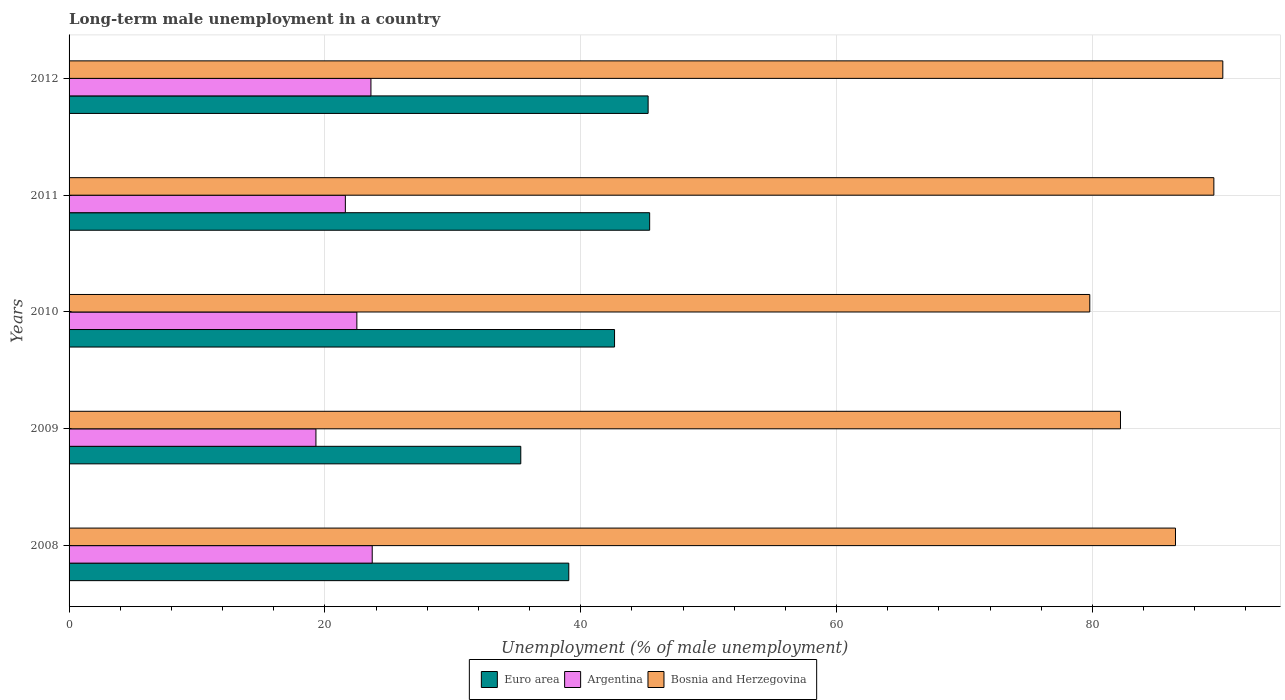How many different coloured bars are there?
Keep it short and to the point. 3. Are the number of bars on each tick of the Y-axis equal?
Offer a terse response. Yes. What is the percentage of long-term unemployed male population in Euro area in 2008?
Provide a succinct answer. 39.07. Across all years, what is the maximum percentage of long-term unemployed male population in Bosnia and Herzegovina?
Your answer should be very brief. 90.2. Across all years, what is the minimum percentage of long-term unemployed male population in Euro area?
Offer a terse response. 35.32. In which year was the percentage of long-term unemployed male population in Bosnia and Herzegovina maximum?
Give a very brief answer. 2012. What is the total percentage of long-term unemployed male population in Euro area in the graph?
Your response must be concise. 207.69. What is the difference between the percentage of long-term unemployed male population in Bosnia and Herzegovina in 2008 and that in 2012?
Give a very brief answer. -3.7. What is the difference between the percentage of long-term unemployed male population in Argentina in 2008 and the percentage of long-term unemployed male population in Bosnia and Herzegovina in 2012?
Your answer should be very brief. -66.5. What is the average percentage of long-term unemployed male population in Argentina per year?
Your response must be concise. 22.14. In the year 2008, what is the difference between the percentage of long-term unemployed male population in Bosnia and Herzegovina and percentage of long-term unemployed male population in Argentina?
Offer a very short reply. 62.8. What is the ratio of the percentage of long-term unemployed male population in Bosnia and Herzegovina in 2011 to that in 2012?
Provide a succinct answer. 0.99. Is the percentage of long-term unemployed male population in Euro area in 2009 less than that in 2011?
Give a very brief answer. Yes. What is the difference between the highest and the second highest percentage of long-term unemployed male population in Argentina?
Offer a very short reply. 0.1. What is the difference between the highest and the lowest percentage of long-term unemployed male population in Argentina?
Make the answer very short. 4.4. In how many years, is the percentage of long-term unemployed male population in Argentina greater than the average percentage of long-term unemployed male population in Argentina taken over all years?
Offer a terse response. 3. Is the sum of the percentage of long-term unemployed male population in Euro area in 2009 and 2011 greater than the maximum percentage of long-term unemployed male population in Argentina across all years?
Provide a short and direct response. Yes. What does the 3rd bar from the top in 2012 represents?
Ensure brevity in your answer.  Euro area. What does the 3rd bar from the bottom in 2009 represents?
Offer a terse response. Bosnia and Herzegovina. Is it the case that in every year, the sum of the percentage of long-term unemployed male population in Euro area and percentage of long-term unemployed male population in Argentina is greater than the percentage of long-term unemployed male population in Bosnia and Herzegovina?
Provide a succinct answer. No. How many bars are there?
Provide a short and direct response. 15. Are all the bars in the graph horizontal?
Give a very brief answer. Yes. How many years are there in the graph?
Your answer should be compact. 5. Are the values on the major ticks of X-axis written in scientific E-notation?
Keep it short and to the point. No. Does the graph contain any zero values?
Offer a very short reply. No. How many legend labels are there?
Give a very brief answer. 3. How are the legend labels stacked?
Offer a very short reply. Horizontal. What is the title of the graph?
Make the answer very short. Long-term male unemployment in a country. What is the label or title of the X-axis?
Give a very brief answer. Unemployment (% of male unemployment). What is the Unemployment (% of male unemployment) in Euro area in 2008?
Offer a terse response. 39.07. What is the Unemployment (% of male unemployment) of Argentina in 2008?
Offer a terse response. 23.7. What is the Unemployment (% of male unemployment) in Bosnia and Herzegovina in 2008?
Provide a succinct answer. 86.5. What is the Unemployment (% of male unemployment) of Euro area in 2009?
Keep it short and to the point. 35.32. What is the Unemployment (% of male unemployment) of Argentina in 2009?
Provide a short and direct response. 19.3. What is the Unemployment (% of male unemployment) in Bosnia and Herzegovina in 2009?
Provide a short and direct response. 82.2. What is the Unemployment (% of male unemployment) in Euro area in 2010?
Your answer should be compact. 42.65. What is the Unemployment (% of male unemployment) of Bosnia and Herzegovina in 2010?
Your answer should be very brief. 79.8. What is the Unemployment (% of male unemployment) of Euro area in 2011?
Make the answer very short. 45.39. What is the Unemployment (% of male unemployment) in Argentina in 2011?
Offer a very short reply. 21.6. What is the Unemployment (% of male unemployment) in Bosnia and Herzegovina in 2011?
Offer a very short reply. 89.5. What is the Unemployment (% of male unemployment) in Euro area in 2012?
Keep it short and to the point. 45.27. What is the Unemployment (% of male unemployment) of Argentina in 2012?
Offer a very short reply. 23.6. What is the Unemployment (% of male unemployment) in Bosnia and Herzegovina in 2012?
Give a very brief answer. 90.2. Across all years, what is the maximum Unemployment (% of male unemployment) of Euro area?
Make the answer very short. 45.39. Across all years, what is the maximum Unemployment (% of male unemployment) of Argentina?
Your answer should be very brief. 23.7. Across all years, what is the maximum Unemployment (% of male unemployment) in Bosnia and Herzegovina?
Give a very brief answer. 90.2. Across all years, what is the minimum Unemployment (% of male unemployment) of Euro area?
Offer a very short reply. 35.32. Across all years, what is the minimum Unemployment (% of male unemployment) in Argentina?
Keep it short and to the point. 19.3. Across all years, what is the minimum Unemployment (% of male unemployment) in Bosnia and Herzegovina?
Ensure brevity in your answer.  79.8. What is the total Unemployment (% of male unemployment) of Euro area in the graph?
Offer a very short reply. 207.69. What is the total Unemployment (% of male unemployment) of Argentina in the graph?
Keep it short and to the point. 110.7. What is the total Unemployment (% of male unemployment) in Bosnia and Herzegovina in the graph?
Offer a very short reply. 428.2. What is the difference between the Unemployment (% of male unemployment) of Euro area in 2008 and that in 2009?
Ensure brevity in your answer.  3.75. What is the difference between the Unemployment (% of male unemployment) in Bosnia and Herzegovina in 2008 and that in 2009?
Offer a terse response. 4.3. What is the difference between the Unemployment (% of male unemployment) in Euro area in 2008 and that in 2010?
Your response must be concise. -3.58. What is the difference between the Unemployment (% of male unemployment) in Euro area in 2008 and that in 2011?
Your answer should be very brief. -6.32. What is the difference between the Unemployment (% of male unemployment) in Euro area in 2008 and that in 2012?
Your answer should be compact. -6.2. What is the difference between the Unemployment (% of male unemployment) of Euro area in 2009 and that in 2010?
Offer a very short reply. -7.33. What is the difference between the Unemployment (% of male unemployment) of Argentina in 2009 and that in 2010?
Your answer should be very brief. -3.2. What is the difference between the Unemployment (% of male unemployment) of Euro area in 2009 and that in 2011?
Give a very brief answer. -10.07. What is the difference between the Unemployment (% of male unemployment) of Euro area in 2009 and that in 2012?
Your answer should be compact. -9.96. What is the difference between the Unemployment (% of male unemployment) of Euro area in 2010 and that in 2011?
Make the answer very short. -2.74. What is the difference between the Unemployment (% of male unemployment) in Argentina in 2010 and that in 2011?
Ensure brevity in your answer.  0.9. What is the difference between the Unemployment (% of male unemployment) in Bosnia and Herzegovina in 2010 and that in 2011?
Keep it short and to the point. -9.7. What is the difference between the Unemployment (% of male unemployment) of Euro area in 2010 and that in 2012?
Make the answer very short. -2.63. What is the difference between the Unemployment (% of male unemployment) of Bosnia and Herzegovina in 2010 and that in 2012?
Give a very brief answer. -10.4. What is the difference between the Unemployment (% of male unemployment) of Euro area in 2011 and that in 2012?
Offer a very short reply. 0.12. What is the difference between the Unemployment (% of male unemployment) of Argentina in 2011 and that in 2012?
Offer a very short reply. -2. What is the difference between the Unemployment (% of male unemployment) of Bosnia and Herzegovina in 2011 and that in 2012?
Keep it short and to the point. -0.7. What is the difference between the Unemployment (% of male unemployment) in Euro area in 2008 and the Unemployment (% of male unemployment) in Argentina in 2009?
Make the answer very short. 19.77. What is the difference between the Unemployment (% of male unemployment) of Euro area in 2008 and the Unemployment (% of male unemployment) of Bosnia and Herzegovina in 2009?
Your answer should be very brief. -43.13. What is the difference between the Unemployment (% of male unemployment) of Argentina in 2008 and the Unemployment (% of male unemployment) of Bosnia and Herzegovina in 2009?
Give a very brief answer. -58.5. What is the difference between the Unemployment (% of male unemployment) in Euro area in 2008 and the Unemployment (% of male unemployment) in Argentina in 2010?
Provide a succinct answer. 16.57. What is the difference between the Unemployment (% of male unemployment) in Euro area in 2008 and the Unemployment (% of male unemployment) in Bosnia and Herzegovina in 2010?
Provide a succinct answer. -40.73. What is the difference between the Unemployment (% of male unemployment) of Argentina in 2008 and the Unemployment (% of male unemployment) of Bosnia and Herzegovina in 2010?
Offer a terse response. -56.1. What is the difference between the Unemployment (% of male unemployment) in Euro area in 2008 and the Unemployment (% of male unemployment) in Argentina in 2011?
Provide a succinct answer. 17.47. What is the difference between the Unemployment (% of male unemployment) of Euro area in 2008 and the Unemployment (% of male unemployment) of Bosnia and Herzegovina in 2011?
Your answer should be very brief. -50.43. What is the difference between the Unemployment (% of male unemployment) of Argentina in 2008 and the Unemployment (% of male unemployment) of Bosnia and Herzegovina in 2011?
Your response must be concise. -65.8. What is the difference between the Unemployment (% of male unemployment) in Euro area in 2008 and the Unemployment (% of male unemployment) in Argentina in 2012?
Provide a succinct answer. 15.47. What is the difference between the Unemployment (% of male unemployment) of Euro area in 2008 and the Unemployment (% of male unemployment) of Bosnia and Herzegovina in 2012?
Provide a succinct answer. -51.13. What is the difference between the Unemployment (% of male unemployment) of Argentina in 2008 and the Unemployment (% of male unemployment) of Bosnia and Herzegovina in 2012?
Ensure brevity in your answer.  -66.5. What is the difference between the Unemployment (% of male unemployment) of Euro area in 2009 and the Unemployment (% of male unemployment) of Argentina in 2010?
Provide a short and direct response. 12.82. What is the difference between the Unemployment (% of male unemployment) in Euro area in 2009 and the Unemployment (% of male unemployment) in Bosnia and Herzegovina in 2010?
Ensure brevity in your answer.  -44.48. What is the difference between the Unemployment (% of male unemployment) of Argentina in 2009 and the Unemployment (% of male unemployment) of Bosnia and Herzegovina in 2010?
Offer a terse response. -60.5. What is the difference between the Unemployment (% of male unemployment) in Euro area in 2009 and the Unemployment (% of male unemployment) in Argentina in 2011?
Keep it short and to the point. 13.72. What is the difference between the Unemployment (% of male unemployment) in Euro area in 2009 and the Unemployment (% of male unemployment) in Bosnia and Herzegovina in 2011?
Provide a short and direct response. -54.18. What is the difference between the Unemployment (% of male unemployment) of Argentina in 2009 and the Unemployment (% of male unemployment) of Bosnia and Herzegovina in 2011?
Give a very brief answer. -70.2. What is the difference between the Unemployment (% of male unemployment) of Euro area in 2009 and the Unemployment (% of male unemployment) of Argentina in 2012?
Provide a short and direct response. 11.72. What is the difference between the Unemployment (% of male unemployment) of Euro area in 2009 and the Unemployment (% of male unemployment) of Bosnia and Herzegovina in 2012?
Give a very brief answer. -54.88. What is the difference between the Unemployment (% of male unemployment) in Argentina in 2009 and the Unemployment (% of male unemployment) in Bosnia and Herzegovina in 2012?
Your response must be concise. -70.9. What is the difference between the Unemployment (% of male unemployment) of Euro area in 2010 and the Unemployment (% of male unemployment) of Argentina in 2011?
Provide a succinct answer. 21.05. What is the difference between the Unemployment (% of male unemployment) of Euro area in 2010 and the Unemployment (% of male unemployment) of Bosnia and Herzegovina in 2011?
Your answer should be compact. -46.85. What is the difference between the Unemployment (% of male unemployment) in Argentina in 2010 and the Unemployment (% of male unemployment) in Bosnia and Herzegovina in 2011?
Make the answer very short. -67. What is the difference between the Unemployment (% of male unemployment) in Euro area in 2010 and the Unemployment (% of male unemployment) in Argentina in 2012?
Keep it short and to the point. 19.05. What is the difference between the Unemployment (% of male unemployment) in Euro area in 2010 and the Unemployment (% of male unemployment) in Bosnia and Herzegovina in 2012?
Your answer should be very brief. -47.55. What is the difference between the Unemployment (% of male unemployment) in Argentina in 2010 and the Unemployment (% of male unemployment) in Bosnia and Herzegovina in 2012?
Ensure brevity in your answer.  -67.7. What is the difference between the Unemployment (% of male unemployment) in Euro area in 2011 and the Unemployment (% of male unemployment) in Argentina in 2012?
Offer a terse response. 21.79. What is the difference between the Unemployment (% of male unemployment) of Euro area in 2011 and the Unemployment (% of male unemployment) of Bosnia and Herzegovina in 2012?
Your answer should be very brief. -44.81. What is the difference between the Unemployment (% of male unemployment) in Argentina in 2011 and the Unemployment (% of male unemployment) in Bosnia and Herzegovina in 2012?
Provide a succinct answer. -68.6. What is the average Unemployment (% of male unemployment) in Euro area per year?
Offer a very short reply. 41.54. What is the average Unemployment (% of male unemployment) of Argentina per year?
Your answer should be compact. 22.14. What is the average Unemployment (% of male unemployment) in Bosnia and Herzegovina per year?
Provide a short and direct response. 85.64. In the year 2008, what is the difference between the Unemployment (% of male unemployment) of Euro area and Unemployment (% of male unemployment) of Argentina?
Provide a succinct answer. 15.37. In the year 2008, what is the difference between the Unemployment (% of male unemployment) in Euro area and Unemployment (% of male unemployment) in Bosnia and Herzegovina?
Your response must be concise. -47.43. In the year 2008, what is the difference between the Unemployment (% of male unemployment) in Argentina and Unemployment (% of male unemployment) in Bosnia and Herzegovina?
Your answer should be compact. -62.8. In the year 2009, what is the difference between the Unemployment (% of male unemployment) in Euro area and Unemployment (% of male unemployment) in Argentina?
Make the answer very short. 16.02. In the year 2009, what is the difference between the Unemployment (% of male unemployment) in Euro area and Unemployment (% of male unemployment) in Bosnia and Herzegovina?
Keep it short and to the point. -46.88. In the year 2009, what is the difference between the Unemployment (% of male unemployment) of Argentina and Unemployment (% of male unemployment) of Bosnia and Herzegovina?
Your answer should be compact. -62.9. In the year 2010, what is the difference between the Unemployment (% of male unemployment) of Euro area and Unemployment (% of male unemployment) of Argentina?
Offer a very short reply. 20.15. In the year 2010, what is the difference between the Unemployment (% of male unemployment) of Euro area and Unemployment (% of male unemployment) of Bosnia and Herzegovina?
Ensure brevity in your answer.  -37.15. In the year 2010, what is the difference between the Unemployment (% of male unemployment) in Argentina and Unemployment (% of male unemployment) in Bosnia and Herzegovina?
Offer a terse response. -57.3. In the year 2011, what is the difference between the Unemployment (% of male unemployment) in Euro area and Unemployment (% of male unemployment) in Argentina?
Make the answer very short. 23.79. In the year 2011, what is the difference between the Unemployment (% of male unemployment) in Euro area and Unemployment (% of male unemployment) in Bosnia and Herzegovina?
Your answer should be compact. -44.11. In the year 2011, what is the difference between the Unemployment (% of male unemployment) of Argentina and Unemployment (% of male unemployment) of Bosnia and Herzegovina?
Provide a short and direct response. -67.9. In the year 2012, what is the difference between the Unemployment (% of male unemployment) in Euro area and Unemployment (% of male unemployment) in Argentina?
Provide a short and direct response. 21.67. In the year 2012, what is the difference between the Unemployment (% of male unemployment) in Euro area and Unemployment (% of male unemployment) in Bosnia and Herzegovina?
Make the answer very short. -44.93. In the year 2012, what is the difference between the Unemployment (% of male unemployment) in Argentina and Unemployment (% of male unemployment) in Bosnia and Herzegovina?
Your answer should be compact. -66.6. What is the ratio of the Unemployment (% of male unemployment) in Euro area in 2008 to that in 2009?
Provide a succinct answer. 1.11. What is the ratio of the Unemployment (% of male unemployment) in Argentina in 2008 to that in 2009?
Provide a succinct answer. 1.23. What is the ratio of the Unemployment (% of male unemployment) of Bosnia and Herzegovina in 2008 to that in 2009?
Your answer should be very brief. 1.05. What is the ratio of the Unemployment (% of male unemployment) of Euro area in 2008 to that in 2010?
Make the answer very short. 0.92. What is the ratio of the Unemployment (% of male unemployment) in Argentina in 2008 to that in 2010?
Provide a succinct answer. 1.05. What is the ratio of the Unemployment (% of male unemployment) of Bosnia and Herzegovina in 2008 to that in 2010?
Your response must be concise. 1.08. What is the ratio of the Unemployment (% of male unemployment) of Euro area in 2008 to that in 2011?
Ensure brevity in your answer.  0.86. What is the ratio of the Unemployment (% of male unemployment) of Argentina in 2008 to that in 2011?
Your answer should be compact. 1.1. What is the ratio of the Unemployment (% of male unemployment) in Bosnia and Herzegovina in 2008 to that in 2011?
Your answer should be compact. 0.97. What is the ratio of the Unemployment (% of male unemployment) of Euro area in 2008 to that in 2012?
Your answer should be very brief. 0.86. What is the ratio of the Unemployment (% of male unemployment) of Euro area in 2009 to that in 2010?
Your answer should be compact. 0.83. What is the ratio of the Unemployment (% of male unemployment) in Argentina in 2009 to that in 2010?
Offer a very short reply. 0.86. What is the ratio of the Unemployment (% of male unemployment) of Bosnia and Herzegovina in 2009 to that in 2010?
Provide a succinct answer. 1.03. What is the ratio of the Unemployment (% of male unemployment) in Euro area in 2009 to that in 2011?
Give a very brief answer. 0.78. What is the ratio of the Unemployment (% of male unemployment) of Argentina in 2009 to that in 2011?
Ensure brevity in your answer.  0.89. What is the ratio of the Unemployment (% of male unemployment) in Bosnia and Herzegovina in 2009 to that in 2011?
Provide a short and direct response. 0.92. What is the ratio of the Unemployment (% of male unemployment) of Euro area in 2009 to that in 2012?
Keep it short and to the point. 0.78. What is the ratio of the Unemployment (% of male unemployment) in Argentina in 2009 to that in 2012?
Your answer should be compact. 0.82. What is the ratio of the Unemployment (% of male unemployment) in Bosnia and Herzegovina in 2009 to that in 2012?
Make the answer very short. 0.91. What is the ratio of the Unemployment (% of male unemployment) of Euro area in 2010 to that in 2011?
Your response must be concise. 0.94. What is the ratio of the Unemployment (% of male unemployment) of Argentina in 2010 to that in 2011?
Offer a terse response. 1.04. What is the ratio of the Unemployment (% of male unemployment) in Bosnia and Herzegovina in 2010 to that in 2011?
Your answer should be very brief. 0.89. What is the ratio of the Unemployment (% of male unemployment) of Euro area in 2010 to that in 2012?
Ensure brevity in your answer.  0.94. What is the ratio of the Unemployment (% of male unemployment) in Argentina in 2010 to that in 2012?
Give a very brief answer. 0.95. What is the ratio of the Unemployment (% of male unemployment) in Bosnia and Herzegovina in 2010 to that in 2012?
Keep it short and to the point. 0.88. What is the ratio of the Unemployment (% of male unemployment) in Euro area in 2011 to that in 2012?
Offer a terse response. 1. What is the ratio of the Unemployment (% of male unemployment) of Argentina in 2011 to that in 2012?
Offer a terse response. 0.92. What is the ratio of the Unemployment (% of male unemployment) of Bosnia and Herzegovina in 2011 to that in 2012?
Provide a succinct answer. 0.99. What is the difference between the highest and the second highest Unemployment (% of male unemployment) in Euro area?
Give a very brief answer. 0.12. What is the difference between the highest and the second highest Unemployment (% of male unemployment) of Argentina?
Give a very brief answer. 0.1. What is the difference between the highest and the lowest Unemployment (% of male unemployment) of Euro area?
Give a very brief answer. 10.07. 